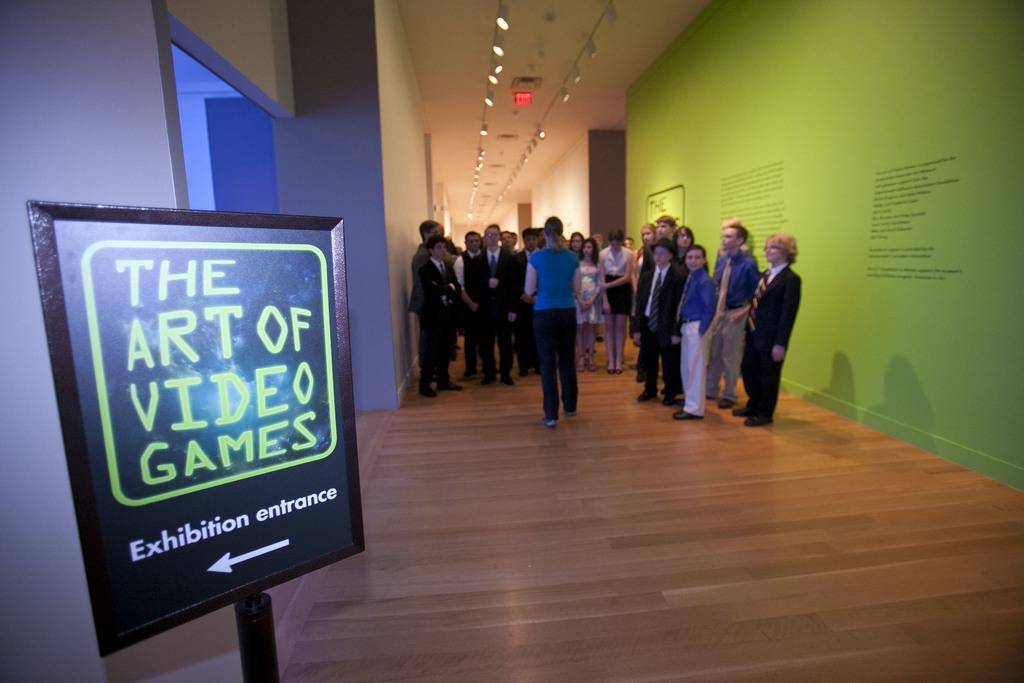What kind of exhibition is this?
Give a very brief answer. The art of video games. What does it say just above the arrow?
Your answer should be very brief. Exhibition entrance. 